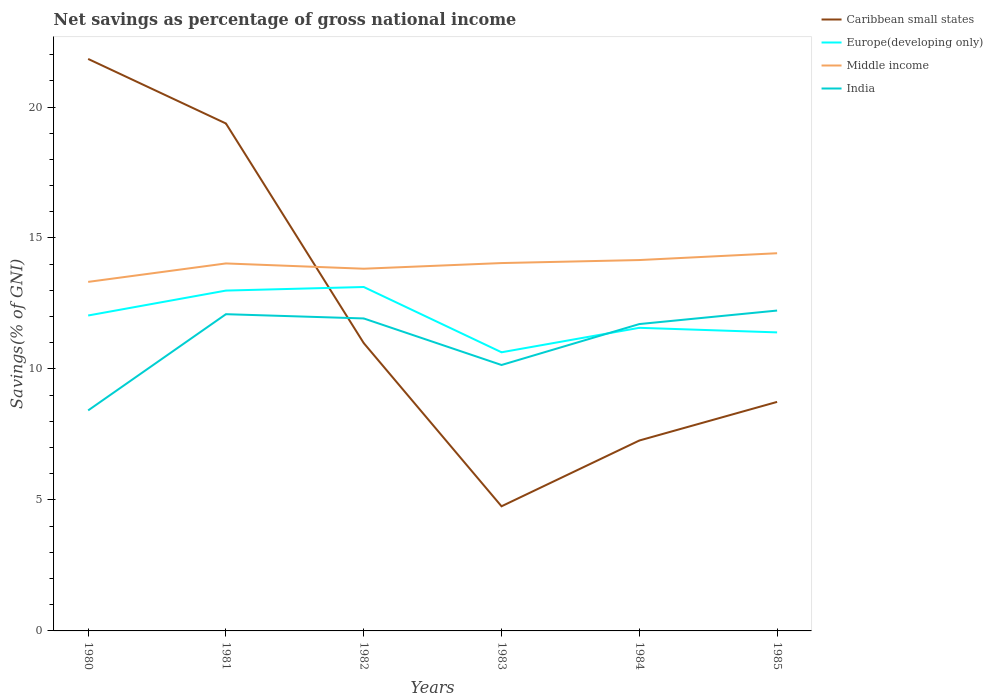How many different coloured lines are there?
Make the answer very short. 4. Does the line corresponding to India intersect with the line corresponding to Europe(developing only)?
Keep it short and to the point. Yes. Is the number of lines equal to the number of legend labels?
Ensure brevity in your answer.  Yes. Across all years, what is the maximum total savings in Middle income?
Keep it short and to the point. 13.32. In which year was the total savings in Caribbean small states maximum?
Your answer should be compact. 1983. What is the total total savings in Europe(developing only) in the graph?
Your response must be concise. 0.64. What is the difference between the highest and the second highest total savings in Caribbean small states?
Ensure brevity in your answer.  17.08. How many lines are there?
Give a very brief answer. 4. Are the values on the major ticks of Y-axis written in scientific E-notation?
Provide a short and direct response. No. Does the graph contain any zero values?
Provide a short and direct response. No. What is the title of the graph?
Offer a very short reply. Net savings as percentage of gross national income. What is the label or title of the Y-axis?
Provide a short and direct response. Savings(% of GNI). What is the Savings(% of GNI) of Caribbean small states in 1980?
Provide a succinct answer. 21.83. What is the Savings(% of GNI) of Europe(developing only) in 1980?
Your answer should be compact. 12.04. What is the Savings(% of GNI) of Middle income in 1980?
Keep it short and to the point. 13.32. What is the Savings(% of GNI) of India in 1980?
Give a very brief answer. 8.42. What is the Savings(% of GNI) of Caribbean small states in 1981?
Give a very brief answer. 19.37. What is the Savings(% of GNI) of Europe(developing only) in 1981?
Your answer should be very brief. 12.99. What is the Savings(% of GNI) in Middle income in 1981?
Provide a short and direct response. 14.03. What is the Savings(% of GNI) of India in 1981?
Offer a terse response. 12.09. What is the Savings(% of GNI) of Caribbean small states in 1982?
Offer a very short reply. 10.99. What is the Savings(% of GNI) of Europe(developing only) in 1982?
Offer a terse response. 13.13. What is the Savings(% of GNI) in Middle income in 1982?
Your answer should be compact. 13.83. What is the Savings(% of GNI) in India in 1982?
Provide a succinct answer. 11.93. What is the Savings(% of GNI) of Caribbean small states in 1983?
Offer a very short reply. 4.76. What is the Savings(% of GNI) of Europe(developing only) in 1983?
Keep it short and to the point. 10.64. What is the Savings(% of GNI) of Middle income in 1983?
Provide a succinct answer. 14.04. What is the Savings(% of GNI) in India in 1983?
Give a very brief answer. 10.15. What is the Savings(% of GNI) in Caribbean small states in 1984?
Keep it short and to the point. 7.27. What is the Savings(% of GNI) of Europe(developing only) in 1984?
Your answer should be very brief. 11.57. What is the Savings(% of GNI) in Middle income in 1984?
Ensure brevity in your answer.  14.16. What is the Savings(% of GNI) in India in 1984?
Ensure brevity in your answer.  11.71. What is the Savings(% of GNI) in Caribbean small states in 1985?
Offer a very short reply. 8.74. What is the Savings(% of GNI) of Europe(developing only) in 1985?
Make the answer very short. 11.4. What is the Savings(% of GNI) in Middle income in 1985?
Offer a terse response. 14.42. What is the Savings(% of GNI) of India in 1985?
Provide a succinct answer. 12.23. Across all years, what is the maximum Savings(% of GNI) of Caribbean small states?
Your answer should be compact. 21.83. Across all years, what is the maximum Savings(% of GNI) in Europe(developing only)?
Make the answer very short. 13.13. Across all years, what is the maximum Savings(% of GNI) in Middle income?
Your response must be concise. 14.42. Across all years, what is the maximum Savings(% of GNI) of India?
Provide a succinct answer. 12.23. Across all years, what is the minimum Savings(% of GNI) in Caribbean small states?
Your answer should be very brief. 4.76. Across all years, what is the minimum Savings(% of GNI) in Europe(developing only)?
Offer a terse response. 10.64. Across all years, what is the minimum Savings(% of GNI) of Middle income?
Your answer should be compact. 13.32. Across all years, what is the minimum Savings(% of GNI) of India?
Offer a very short reply. 8.42. What is the total Savings(% of GNI) in Caribbean small states in the graph?
Give a very brief answer. 72.96. What is the total Savings(% of GNI) of Europe(developing only) in the graph?
Provide a succinct answer. 71.77. What is the total Savings(% of GNI) in Middle income in the graph?
Make the answer very short. 83.8. What is the total Savings(% of GNI) of India in the graph?
Your response must be concise. 66.53. What is the difference between the Savings(% of GNI) in Caribbean small states in 1980 and that in 1981?
Offer a very short reply. 2.46. What is the difference between the Savings(% of GNI) of Europe(developing only) in 1980 and that in 1981?
Your response must be concise. -0.95. What is the difference between the Savings(% of GNI) of Middle income in 1980 and that in 1981?
Your response must be concise. -0.7. What is the difference between the Savings(% of GNI) in India in 1980 and that in 1981?
Give a very brief answer. -3.67. What is the difference between the Savings(% of GNI) of Caribbean small states in 1980 and that in 1982?
Keep it short and to the point. 10.85. What is the difference between the Savings(% of GNI) in Europe(developing only) in 1980 and that in 1982?
Your answer should be compact. -1.09. What is the difference between the Savings(% of GNI) in Middle income in 1980 and that in 1982?
Offer a terse response. -0.5. What is the difference between the Savings(% of GNI) in India in 1980 and that in 1982?
Your answer should be very brief. -3.51. What is the difference between the Savings(% of GNI) of Caribbean small states in 1980 and that in 1983?
Ensure brevity in your answer.  17.08. What is the difference between the Savings(% of GNI) of Europe(developing only) in 1980 and that in 1983?
Keep it short and to the point. 1.4. What is the difference between the Savings(% of GNI) in Middle income in 1980 and that in 1983?
Offer a terse response. -0.72. What is the difference between the Savings(% of GNI) of India in 1980 and that in 1983?
Ensure brevity in your answer.  -1.73. What is the difference between the Savings(% of GNI) of Caribbean small states in 1980 and that in 1984?
Provide a succinct answer. 14.57. What is the difference between the Savings(% of GNI) in Europe(developing only) in 1980 and that in 1984?
Offer a very short reply. 0.47. What is the difference between the Savings(% of GNI) in Middle income in 1980 and that in 1984?
Keep it short and to the point. -0.83. What is the difference between the Savings(% of GNI) in India in 1980 and that in 1984?
Provide a succinct answer. -3.3. What is the difference between the Savings(% of GNI) of Caribbean small states in 1980 and that in 1985?
Offer a terse response. 13.09. What is the difference between the Savings(% of GNI) in Europe(developing only) in 1980 and that in 1985?
Provide a short and direct response. 0.64. What is the difference between the Savings(% of GNI) of Middle income in 1980 and that in 1985?
Make the answer very short. -1.09. What is the difference between the Savings(% of GNI) of India in 1980 and that in 1985?
Provide a short and direct response. -3.81. What is the difference between the Savings(% of GNI) in Caribbean small states in 1981 and that in 1982?
Offer a very short reply. 8.38. What is the difference between the Savings(% of GNI) of Europe(developing only) in 1981 and that in 1982?
Provide a short and direct response. -0.14. What is the difference between the Savings(% of GNI) of Middle income in 1981 and that in 1982?
Your response must be concise. 0.2. What is the difference between the Savings(% of GNI) of India in 1981 and that in 1982?
Ensure brevity in your answer.  0.16. What is the difference between the Savings(% of GNI) in Caribbean small states in 1981 and that in 1983?
Your answer should be very brief. 14.61. What is the difference between the Savings(% of GNI) of Europe(developing only) in 1981 and that in 1983?
Provide a short and direct response. 2.36. What is the difference between the Savings(% of GNI) in Middle income in 1981 and that in 1983?
Keep it short and to the point. -0.01. What is the difference between the Savings(% of GNI) of India in 1981 and that in 1983?
Your answer should be very brief. 1.94. What is the difference between the Savings(% of GNI) in Caribbean small states in 1981 and that in 1984?
Ensure brevity in your answer.  12.1. What is the difference between the Savings(% of GNI) of Europe(developing only) in 1981 and that in 1984?
Your answer should be compact. 1.42. What is the difference between the Savings(% of GNI) of Middle income in 1981 and that in 1984?
Offer a very short reply. -0.13. What is the difference between the Savings(% of GNI) of India in 1981 and that in 1984?
Ensure brevity in your answer.  0.38. What is the difference between the Savings(% of GNI) in Caribbean small states in 1981 and that in 1985?
Offer a terse response. 10.63. What is the difference between the Savings(% of GNI) of Europe(developing only) in 1981 and that in 1985?
Give a very brief answer. 1.6. What is the difference between the Savings(% of GNI) of Middle income in 1981 and that in 1985?
Provide a succinct answer. -0.39. What is the difference between the Savings(% of GNI) in India in 1981 and that in 1985?
Make the answer very short. -0.14. What is the difference between the Savings(% of GNI) in Caribbean small states in 1982 and that in 1983?
Offer a terse response. 6.23. What is the difference between the Savings(% of GNI) of Europe(developing only) in 1982 and that in 1983?
Your answer should be compact. 2.49. What is the difference between the Savings(% of GNI) in Middle income in 1982 and that in 1983?
Make the answer very short. -0.22. What is the difference between the Savings(% of GNI) of India in 1982 and that in 1983?
Keep it short and to the point. 1.78. What is the difference between the Savings(% of GNI) in Caribbean small states in 1982 and that in 1984?
Provide a succinct answer. 3.72. What is the difference between the Savings(% of GNI) in Europe(developing only) in 1982 and that in 1984?
Ensure brevity in your answer.  1.56. What is the difference between the Savings(% of GNI) of Middle income in 1982 and that in 1984?
Make the answer very short. -0.33. What is the difference between the Savings(% of GNI) in India in 1982 and that in 1984?
Your answer should be very brief. 0.21. What is the difference between the Savings(% of GNI) in Caribbean small states in 1982 and that in 1985?
Make the answer very short. 2.25. What is the difference between the Savings(% of GNI) in Europe(developing only) in 1982 and that in 1985?
Keep it short and to the point. 1.73. What is the difference between the Savings(% of GNI) of Middle income in 1982 and that in 1985?
Your answer should be compact. -0.59. What is the difference between the Savings(% of GNI) of India in 1982 and that in 1985?
Offer a very short reply. -0.3. What is the difference between the Savings(% of GNI) of Caribbean small states in 1983 and that in 1984?
Keep it short and to the point. -2.51. What is the difference between the Savings(% of GNI) of Europe(developing only) in 1983 and that in 1984?
Keep it short and to the point. -0.93. What is the difference between the Savings(% of GNI) of Middle income in 1983 and that in 1984?
Keep it short and to the point. -0.12. What is the difference between the Savings(% of GNI) of India in 1983 and that in 1984?
Ensure brevity in your answer.  -1.56. What is the difference between the Savings(% of GNI) in Caribbean small states in 1983 and that in 1985?
Your response must be concise. -3.98. What is the difference between the Savings(% of GNI) in Europe(developing only) in 1983 and that in 1985?
Your response must be concise. -0.76. What is the difference between the Savings(% of GNI) in Middle income in 1983 and that in 1985?
Provide a succinct answer. -0.38. What is the difference between the Savings(% of GNI) in India in 1983 and that in 1985?
Ensure brevity in your answer.  -2.08. What is the difference between the Savings(% of GNI) of Caribbean small states in 1984 and that in 1985?
Your answer should be very brief. -1.47. What is the difference between the Savings(% of GNI) of Europe(developing only) in 1984 and that in 1985?
Make the answer very short. 0.17. What is the difference between the Savings(% of GNI) in Middle income in 1984 and that in 1985?
Give a very brief answer. -0.26. What is the difference between the Savings(% of GNI) of India in 1984 and that in 1985?
Ensure brevity in your answer.  -0.52. What is the difference between the Savings(% of GNI) in Caribbean small states in 1980 and the Savings(% of GNI) in Europe(developing only) in 1981?
Give a very brief answer. 8.84. What is the difference between the Savings(% of GNI) in Caribbean small states in 1980 and the Savings(% of GNI) in Middle income in 1981?
Your response must be concise. 7.81. What is the difference between the Savings(% of GNI) of Caribbean small states in 1980 and the Savings(% of GNI) of India in 1981?
Provide a short and direct response. 9.74. What is the difference between the Savings(% of GNI) in Europe(developing only) in 1980 and the Savings(% of GNI) in Middle income in 1981?
Offer a very short reply. -1.99. What is the difference between the Savings(% of GNI) of Europe(developing only) in 1980 and the Savings(% of GNI) of India in 1981?
Provide a short and direct response. -0.05. What is the difference between the Savings(% of GNI) of Middle income in 1980 and the Savings(% of GNI) of India in 1981?
Keep it short and to the point. 1.23. What is the difference between the Savings(% of GNI) of Caribbean small states in 1980 and the Savings(% of GNI) of Europe(developing only) in 1982?
Your response must be concise. 8.71. What is the difference between the Savings(% of GNI) of Caribbean small states in 1980 and the Savings(% of GNI) of Middle income in 1982?
Your answer should be compact. 8.01. What is the difference between the Savings(% of GNI) of Caribbean small states in 1980 and the Savings(% of GNI) of India in 1982?
Give a very brief answer. 9.91. What is the difference between the Savings(% of GNI) of Europe(developing only) in 1980 and the Savings(% of GNI) of Middle income in 1982?
Offer a very short reply. -1.79. What is the difference between the Savings(% of GNI) in Europe(developing only) in 1980 and the Savings(% of GNI) in India in 1982?
Your answer should be compact. 0.11. What is the difference between the Savings(% of GNI) of Middle income in 1980 and the Savings(% of GNI) of India in 1982?
Your answer should be compact. 1.4. What is the difference between the Savings(% of GNI) in Caribbean small states in 1980 and the Savings(% of GNI) in Europe(developing only) in 1983?
Give a very brief answer. 11.2. What is the difference between the Savings(% of GNI) in Caribbean small states in 1980 and the Savings(% of GNI) in Middle income in 1983?
Your answer should be very brief. 7.79. What is the difference between the Savings(% of GNI) of Caribbean small states in 1980 and the Savings(% of GNI) of India in 1983?
Ensure brevity in your answer.  11.68. What is the difference between the Savings(% of GNI) in Europe(developing only) in 1980 and the Savings(% of GNI) in Middle income in 1983?
Provide a short and direct response. -2. What is the difference between the Savings(% of GNI) of Europe(developing only) in 1980 and the Savings(% of GNI) of India in 1983?
Give a very brief answer. 1.89. What is the difference between the Savings(% of GNI) of Middle income in 1980 and the Savings(% of GNI) of India in 1983?
Your response must be concise. 3.17. What is the difference between the Savings(% of GNI) in Caribbean small states in 1980 and the Savings(% of GNI) in Europe(developing only) in 1984?
Your response must be concise. 10.26. What is the difference between the Savings(% of GNI) of Caribbean small states in 1980 and the Savings(% of GNI) of Middle income in 1984?
Keep it short and to the point. 7.68. What is the difference between the Savings(% of GNI) of Caribbean small states in 1980 and the Savings(% of GNI) of India in 1984?
Ensure brevity in your answer.  10.12. What is the difference between the Savings(% of GNI) in Europe(developing only) in 1980 and the Savings(% of GNI) in Middle income in 1984?
Give a very brief answer. -2.12. What is the difference between the Savings(% of GNI) in Europe(developing only) in 1980 and the Savings(% of GNI) in India in 1984?
Offer a very short reply. 0.33. What is the difference between the Savings(% of GNI) of Middle income in 1980 and the Savings(% of GNI) of India in 1984?
Offer a very short reply. 1.61. What is the difference between the Savings(% of GNI) in Caribbean small states in 1980 and the Savings(% of GNI) in Europe(developing only) in 1985?
Your answer should be compact. 10.44. What is the difference between the Savings(% of GNI) in Caribbean small states in 1980 and the Savings(% of GNI) in Middle income in 1985?
Your answer should be very brief. 7.42. What is the difference between the Savings(% of GNI) in Caribbean small states in 1980 and the Savings(% of GNI) in India in 1985?
Your answer should be compact. 9.61. What is the difference between the Savings(% of GNI) in Europe(developing only) in 1980 and the Savings(% of GNI) in Middle income in 1985?
Give a very brief answer. -2.38. What is the difference between the Savings(% of GNI) in Europe(developing only) in 1980 and the Savings(% of GNI) in India in 1985?
Provide a short and direct response. -0.19. What is the difference between the Savings(% of GNI) of Middle income in 1980 and the Savings(% of GNI) of India in 1985?
Ensure brevity in your answer.  1.09. What is the difference between the Savings(% of GNI) in Caribbean small states in 1981 and the Savings(% of GNI) in Europe(developing only) in 1982?
Ensure brevity in your answer.  6.24. What is the difference between the Savings(% of GNI) in Caribbean small states in 1981 and the Savings(% of GNI) in Middle income in 1982?
Provide a succinct answer. 5.54. What is the difference between the Savings(% of GNI) in Caribbean small states in 1981 and the Savings(% of GNI) in India in 1982?
Provide a short and direct response. 7.44. What is the difference between the Savings(% of GNI) of Europe(developing only) in 1981 and the Savings(% of GNI) of Middle income in 1982?
Offer a very short reply. -0.83. What is the difference between the Savings(% of GNI) of Europe(developing only) in 1981 and the Savings(% of GNI) of India in 1982?
Make the answer very short. 1.06. What is the difference between the Savings(% of GNI) in Middle income in 1981 and the Savings(% of GNI) in India in 1982?
Keep it short and to the point. 2.1. What is the difference between the Savings(% of GNI) in Caribbean small states in 1981 and the Savings(% of GNI) in Europe(developing only) in 1983?
Your response must be concise. 8.73. What is the difference between the Savings(% of GNI) in Caribbean small states in 1981 and the Savings(% of GNI) in Middle income in 1983?
Provide a succinct answer. 5.33. What is the difference between the Savings(% of GNI) of Caribbean small states in 1981 and the Savings(% of GNI) of India in 1983?
Provide a short and direct response. 9.22. What is the difference between the Savings(% of GNI) of Europe(developing only) in 1981 and the Savings(% of GNI) of Middle income in 1983?
Offer a very short reply. -1.05. What is the difference between the Savings(% of GNI) of Europe(developing only) in 1981 and the Savings(% of GNI) of India in 1983?
Your answer should be compact. 2.84. What is the difference between the Savings(% of GNI) in Middle income in 1981 and the Savings(% of GNI) in India in 1983?
Ensure brevity in your answer.  3.88. What is the difference between the Savings(% of GNI) in Caribbean small states in 1981 and the Savings(% of GNI) in Europe(developing only) in 1984?
Offer a terse response. 7.8. What is the difference between the Savings(% of GNI) of Caribbean small states in 1981 and the Savings(% of GNI) of Middle income in 1984?
Your answer should be very brief. 5.21. What is the difference between the Savings(% of GNI) in Caribbean small states in 1981 and the Savings(% of GNI) in India in 1984?
Your answer should be compact. 7.66. What is the difference between the Savings(% of GNI) of Europe(developing only) in 1981 and the Savings(% of GNI) of Middle income in 1984?
Provide a short and direct response. -1.17. What is the difference between the Savings(% of GNI) in Europe(developing only) in 1981 and the Savings(% of GNI) in India in 1984?
Provide a short and direct response. 1.28. What is the difference between the Savings(% of GNI) of Middle income in 1981 and the Savings(% of GNI) of India in 1984?
Provide a succinct answer. 2.31. What is the difference between the Savings(% of GNI) in Caribbean small states in 1981 and the Savings(% of GNI) in Europe(developing only) in 1985?
Give a very brief answer. 7.97. What is the difference between the Savings(% of GNI) in Caribbean small states in 1981 and the Savings(% of GNI) in Middle income in 1985?
Provide a succinct answer. 4.95. What is the difference between the Savings(% of GNI) in Caribbean small states in 1981 and the Savings(% of GNI) in India in 1985?
Offer a terse response. 7.14. What is the difference between the Savings(% of GNI) in Europe(developing only) in 1981 and the Savings(% of GNI) in Middle income in 1985?
Your answer should be very brief. -1.43. What is the difference between the Savings(% of GNI) in Europe(developing only) in 1981 and the Savings(% of GNI) in India in 1985?
Your answer should be very brief. 0.76. What is the difference between the Savings(% of GNI) of Middle income in 1981 and the Savings(% of GNI) of India in 1985?
Your response must be concise. 1.8. What is the difference between the Savings(% of GNI) in Caribbean small states in 1982 and the Savings(% of GNI) in Europe(developing only) in 1983?
Give a very brief answer. 0.35. What is the difference between the Savings(% of GNI) of Caribbean small states in 1982 and the Savings(% of GNI) of Middle income in 1983?
Provide a short and direct response. -3.05. What is the difference between the Savings(% of GNI) in Caribbean small states in 1982 and the Savings(% of GNI) in India in 1983?
Provide a succinct answer. 0.84. What is the difference between the Savings(% of GNI) in Europe(developing only) in 1982 and the Savings(% of GNI) in Middle income in 1983?
Offer a very short reply. -0.91. What is the difference between the Savings(% of GNI) of Europe(developing only) in 1982 and the Savings(% of GNI) of India in 1983?
Make the answer very short. 2.98. What is the difference between the Savings(% of GNI) of Middle income in 1982 and the Savings(% of GNI) of India in 1983?
Provide a short and direct response. 3.68. What is the difference between the Savings(% of GNI) of Caribbean small states in 1982 and the Savings(% of GNI) of Europe(developing only) in 1984?
Offer a terse response. -0.58. What is the difference between the Savings(% of GNI) of Caribbean small states in 1982 and the Savings(% of GNI) of Middle income in 1984?
Your response must be concise. -3.17. What is the difference between the Savings(% of GNI) of Caribbean small states in 1982 and the Savings(% of GNI) of India in 1984?
Your answer should be compact. -0.73. What is the difference between the Savings(% of GNI) of Europe(developing only) in 1982 and the Savings(% of GNI) of Middle income in 1984?
Provide a succinct answer. -1.03. What is the difference between the Savings(% of GNI) of Europe(developing only) in 1982 and the Savings(% of GNI) of India in 1984?
Provide a succinct answer. 1.41. What is the difference between the Savings(% of GNI) of Middle income in 1982 and the Savings(% of GNI) of India in 1984?
Offer a very short reply. 2.11. What is the difference between the Savings(% of GNI) in Caribbean small states in 1982 and the Savings(% of GNI) in Europe(developing only) in 1985?
Your answer should be compact. -0.41. What is the difference between the Savings(% of GNI) of Caribbean small states in 1982 and the Savings(% of GNI) of Middle income in 1985?
Ensure brevity in your answer.  -3.43. What is the difference between the Savings(% of GNI) in Caribbean small states in 1982 and the Savings(% of GNI) in India in 1985?
Your response must be concise. -1.24. What is the difference between the Savings(% of GNI) in Europe(developing only) in 1982 and the Savings(% of GNI) in Middle income in 1985?
Your response must be concise. -1.29. What is the difference between the Savings(% of GNI) in Europe(developing only) in 1982 and the Savings(% of GNI) in India in 1985?
Offer a terse response. 0.9. What is the difference between the Savings(% of GNI) in Middle income in 1982 and the Savings(% of GNI) in India in 1985?
Your answer should be very brief. 1.6. What is the difference between the Savings(% of GNI) in Caribbean small states in 1983 and the Savings(% of GNI) in Europe(developing only) in 1984?
Make the answer very short. -6.81. What is the difference between the Savings(% of GNI) in Caribbean small states in 1983 and the Savings(% of GNI) in Middle income in 1984?
Your answer should be very brief. -9.4. What is the difference between the Savings(% of GNI) in Caribbean small states in 1983 and the Savings(% of GNI) in India in 1984?
Provide a succinct answer. -6.96. What is the difference between the Savings(% of GNI) of Europe(developing only) in 1983 and the Savings(% of GNI) of Middle income in 1984?
Ensure brevity in your answer.  -3.52. What is the difference between the Savings(% of GNI) of Europe(developing only) in 1983 and the Savings(% of GNI) of India in 1984?
Provide a short and direct response. -1.08. What is the difference between the Savings(% of GNI) in Middle income in 1983 and the Savings(% of GNI) in India in 1984?
Make the answer very short. 2.33. What is the difference between the Savings(% of GNI) in Caribbean small states in 1983 and the Savings(% of GNI) in Europe(developing only) in 1985?
Your answer should be very brief. -6.64. What is the difference between the Savings(% of GNI) in Caribbean small states in 1983 and the Savings(% of GNI) in Middle income in 1985?
Give a very brief answer. -9.66. What is the difference between the Savings(% of GNI) in Caribbean small states in 1983 and the Savings(% of GNI) in India in 1985?
Provide a succinct answer. -7.47. What is the difference between the Savings(% of GNI) of Europe(developing only) in 1983 and the Savings(% of GNI) of Middle income in 1985?
Give a very brief answer. -3.78. What is the difference between the Savings(% of GNI) of Europe(developing only) in 1983 and the Savings(% of GNI) of India in 1985?
Your answer should be very brief. -1.59. What is the difference between the Savings(% of GNI) in Middle income in 1983 and the Savings(% of GNI) in India in 1985?
Your answer should be very brief. 1.81. What is the difference between the Savings(% of GNI) of Caribbean small states in 1984 and the Savings(% of GNI) of Europe(developing only) in 1985?
Your response must be concise. -4.13. What is the difference between the Savings(% of GNI) of Caribbean small states in 1984 and the Savings(% of GNI) of Middle income in 1985?
Your answer should be very brief. -7.15. What is the difference between the Savings(% of GNI) of Caribbean small states in 1984 and the Savings(% of GNI) of India in 1985?
Keep it short and to the point. -4.96. What is the difference between the Savings(% of GNI) of Europe(developing only) in 1984 and the Savings(% of GNI) of Middle income in 1985?
Keep it short and to the point. -2.85. What is the difference between the Savings(% of GNI) of Europe(developing only) in 1984 and the Savings(% of GNI) of India in 1985?
Your answer should be compact. -0.66. What is the difference between the Savings(% of GNI) in Middle income in 1984 and the Savings(% of GNI) in India in 1985?
Provide a succinct answer. 1.93. What is the average Savings(% of GNI) of Caribbean small states per year?
Make the answer very short. 12.16. What is the average Savings(% of GNI) in Europe(developing only) per year?
Give a very brief answer. 11.96. What is the average Savings(% of GNI) in Middle income per year?
Your response must be concise. 13.97. What is the average Savings(% of GNI) of India per year?
Give a very brief answer. 11.09. In the year 1980, what is the difference between the Savings(% of GNI) of Caribbean small states and Savings(% of GNI) of Europe(developing only)?
Provide a short and direct response. 9.79. In the year 1980, what is the difference between the Savings(% of GNI) of Caribbean small states and Savings(% of GNI) of Middle income?
Keep it short and to the point. 8.51. In the year 1980, what is the difference between the Savings(% of GNI) in Caribbean small states and Savings(% of GNI) in India?
Ensure brevity in your answer.  13.42. In the year 1980, what is the difference between the Savings(% of GNI) of Europe(developing only) and Savings(% of GNI) of Middle income?
Offer a terse response. -1.28. In the year 1980, what is the difference between the Savings(% of GNI) of Europe(developing only) and Savings(% of GNI) of India?
Offer a terse response. 3.62. In the year 1980, what is the difference between the Savings(% of GNI) in Middle income and Savings(% of GNI) in India?
Provide a short and direct response. 4.91. In the year 1981, what is the difference between the Savings(% of GNI) in Caribbean small states and Savings(% of GNI) in Europe(developing only)?
Offer a terse response. 6.38. In the year 1981, what is the difference between the Savings(% of GNI) of Caribbean small states and Savings(% of GNI) of Middle income?
Offer a very short reply. 5.34. In the year 1981, what is the difference between the Savings(% of GNI) of Caribbean small states and Savings(% of GNI) of India?
Your answer should be compact. 7.28. In the year 1981, what is the difference between the Savings(% of GNI) in Europe(developing only) and Savings(% of GNI) in Middle income?
Provide a short and direct response. -1.04. In the year 1981, what is the difference between the Savings(% of GNI) in Europe(developing only) and Savings(% of GNI) in India?
Offer a terse response. 0.9. In the year 1981, what is the difference between the Savings(% of GNI) of Middle income and Savings(% of GNI) of India?
Give a very brief answer. 1.94. In the year 1982, what is the difference between the Savings(% of GNI) in Caribbean small states and Savings(% of GNI) in Europe(developing only)?
Give a very brief answer. -2.14. In the year 1982, what is the difference between the Savings(% of GNI) in Caribbean small states and Savings(% of GNI) in Middle income?
Ensure brevity in your answer.  -2.84. In the year 1982, what is the difference between the Savings(% of GNI) of Caribbean small states and Savings(% of GNI) of India?
Ensure brevity in your answer.  -0.94. In the year 1982, what is the difference between the Savings(% of GNI) of Europe(developing only) and Savings(% of GNI) of Middle income?
Offer a very short reply. -0.7. In the year 1982, what is the difference between the Savings(% of GNI) in Europe(developing only) and Savings(% of GNI) in India?
Provide a succinct answer. 1.2. In the year 1982, what is the difference between the Savings(% of GNI) of Middle income and Savings(% of GNI) of India?
Offer a very short reply. 1.9. In the year 1983, what is the difference between the Savings(% of GNI) of Caribbean small states and Savings(% of GNI) of Europe(developing only)?
Your response must be concise. -5.88. In the year 1983, what is the difference between the Savings(% of GNI) of Caribbean small states and Savings(% of GNI) of Middle income?
Your answer should be very brief. -9.28. In the year 1983, what is the difference between the Savings(% of GNI) of Caribbean small states and Savings(% of GNI) of India?
Make the answer very short. -5.39. In the year 1983, what is the difference between the Savings(% of GNI) in Europe(developing only) and Savings(% of GNI) in Middle income?
Make the answer very short. -3.41. In the year 1983, what is the difference between the Savings(% of GNI) of Europe(developing only) and Savings(% of GNI) of India?
Your answer should be very brief. 0.49. In the year 1983, what is the difference between the Savings(% of GNI) in Middle income and Savings(% of GNI) in India?
Offer a terse response. 3.89. In the year 1984, what is the difference between the Savings(% of GNI) of Caribbean small states and Savings(% of GNI) of Europe(developing only)?
Offer a very short reply. -4.3. In the year 1984, what is the difference between the Savings(% of GNI) in Caribbean small states and Savings(% of GNI) in Middle income?
Provide a short and direct response. -6.89. In the year 1984, what is the difference between the Savings(% of GNI) of Caribbean small states and Savings(% of GNI) of India?
Make the answer very short. -4.45. In the year 1984, what is the difference between the Savings(% of GNI) of Europe(developing only) and Savings(% of GNI) of Middle income?
Make the answer very short. -2.59. In the year 1984, what is the difference between the Savings(% of GNI) in Europe(developing only) and Savings(% of GNI) in India?
Your response must be concise. -0.14. In the year 1984, what is the difference between the Savings(% of GNI) in Middle income and Savings(% of GNI) in India?
Provide a succinct answer. 2.44. In the year 1985, what is the difference between the Savings(% of GNI) in Caribbean small states and Savings(% of GNI) in Europe(developing only)?
Keep it short and to the point. -2.65. In the year 1985, what is the difference between the Savings(% of GNI) in Caribbean small states and Savings(% of GNI) in Middle income?
Offer a terse response. -5.68. In the year 1985, what is the difference between the Savings(% of GNI) of Caribbean small states and Savings(% of GNI) of India?
Provide a short and direct response. -3.49. In the year 1985, what is the difference between the Savings(% of GNI) of Europe(developing only) and Savings(% of GNI) of Middle income?
Provide a short and direct response. -3.02. In the year 1985, what is the difference between the Savings(% of GNI) in Europe(developing only) and Savings(% of GNI) in India?
Keep it short and to the point. -0.83. In the year 1985, what is the difference between the Savings(% of GNI) in Middle income and Savings(% of GNI) in India?
Provide a succinct answer. 2.19. What is the ratio of the Savings(% of GNI) in Caribbean small states in 1980 to that in 1981?
Offer a terse response. 1.13. What is the ratio of the Savings(% of GNI) in Europe(developing only) in 1980 to that in 1981?
Keep it short and to the point. 0.93. What is the ratio of the Savings(% of GNI) of Middle income in 1980 to that in 1981?
Offer a very short reply. 0.95. What is the ratio of the Savings(% of GNI) of India in 1980 to that in 1981?
Offer a terse response. 0.7. What is the ratio of the Savings(% of GNI) in Caribbean small states in 1980 to that in 1982?
Provide a succinct answer. 1.99. What is the ratio of the Savings(% of GNI) of Europe(developing only) in 1980 to that in 1982?
Provide a succinct answer. 0.92. What is the ratio of the Savings(% of GNI) in Middle income in 1980 to that in 1982?
Provide a short and direct response. 0.96. What is the ratio of the Savings(% of GNI) of India in 1980 to that in 1982?
Give a very brief answer. 0.71. What is the ratio of the Savings(% of GNI) of Caribbean small states in 1980 to that in 1983?
Your answer should be compact. 4.59. What is the ratio of the Savings(% of GNI) in Europe(developing only) in 1980 to that in 1983?
Make the answer very short. 1.13. What is the ratio of the Savings(% of GNI) of Middle income in 1980 to that in 1983?
Your response must be concise. 0.95. What is the ratio of the Savings(% of GNI) in India in 1980 to that in 1983?
Ensure brevity in your answer.  0.83. What is the ratio of the Savings(% of GNI) of Caribbean small states in 1980 to that in 1984?
Your answer should be compact. 3. What is the ratio of the Savings(% of GNI) of Europe(developing only) in 1980 to that in 1984?
Make the answer very short. 1.04. What is the ratio of the Savings(% of GNI) in Middle income in 1980 to that in 1984?
Provide a succinct answer. 0.94. What is the ratio of the Savings(% of GNI) in India in 1980 to that in 1984?
Make the answer very short. 0.72. What is the ratio of the Savings(% of GNI) in Caribbean small states in 1980 to that in 1985?
Give a very brief answer. 2.5. What is the ratio of the Savings(% of GNI) in Europe(developing only) in 1980 to that in 1985?
Offer a terse response. 1.06. What is the ratio of the Savings(% of GNI) in Middle income in 1980 to that in 1985?
Offer a very short reply. 0.92. What is the ratio of the Savings(% of GNI) in India in 1980 to that in 1985?
Your answer should be very brief. 0.69. What is the ratio of the Savings(% of GNI) in Caribbean small states in 1981 to that in 1982?
Keep it short and to the point. 1.76. What is the ratio of the Savings(% of GNI) of Middle income in 1981 to that in 1982?
Provide a succinct answer. 1.01. What is the ratio of the Savings(% of GNI) in India in 1981 to that in 1982?
Offer a terse response. 1.01. What is the ratio of the Savings(% of GNI) in Caribbean small states in 1981 to that in 1983?
Make the answer very short. 4.07. What is the ratio of the Savings(% of GNI) of Europe(developing only) in 1981 to that in 1983?
Give a very brief answer. 1.22. What is the ratio of the Savings(% of GNI) of India in 1981 to that in 1983?
Your response must be concise. 1.19. What is the ratio of the Savings(% of GNI) of Caribbean small states in 1981 to that in 1984?
Provide a succinct answer. 2.67. What is the ratio of the Savings(% of GNI) in Europe(developing only) in 1981 to that in 1984?
Provide a succinct answer. 1.12. What is the ratio of the Savings(% of GNI) in Middle income in 1981 to that in 1984?
Your response must be concise. 0.99. What is the ratio of the Savings(% of GNI) of India in 1981 to that in 1984?
Offer a terse response. 1.03. What is the ratio of the Savings(% of GNI) of Caribbean small states in 1981 to that in 1985?
Offer a terse response. 2.22. What is the ratio of the Savings(% of GNI) in Europe(developing only) in 1981 to that in 1985?
Keep it short and to the point. 1.14. What is the ratio of the Savings(% of GNI) in India in 1981 to that in 1985?
Keep it short and to the point. 0.99. What is the ratio of the Savings(% of GNI) of Caribbean small states in 1982 to that in 1983?
Provide a succinct answer. 2.31. What is the ratio of the Savings(% of GNI) in Europe(developing only) in 1982 to that in 1983?
Your response must be concise. 1.23. What is the ratio of the Savings(% of GNI) in Middle income in 1982 to that in 1983?
Give a very brief answer. 0.98. What is the ratio of the Savings(% of GNI) in India in 1982 to that in 1983?
Provide a succinct answer. 1.18. What is the ratio of the Savings(% of GNI) of Caribbean small states in 1982 to that in 1984?
Make the answer very short. 1.51. What is the ratio of the Savings(% of GNI) of Europe(developing only) in 1982 to that in 1984?
Your answer should be very brief. 1.13. What is the ratio of the Savings(% of GNI) in Middle income in 1982 to that in 1984?
Keep it short and to the point. 0.98. What is the ratio of the Savings(% of GNI) of India in 1982 to that in 1984?
Provide a short and direct response. 1.02. What is the ratio of the Savings(% of GNI) of Caribbean small states in 1982 to that in 1985?
Make the answer very short. 1.26. What is the ratio of the Savings(% of GNI) of Europe(developing only) in 1982 to that in 1985?
Offer a very short reply. 1.15. What is the ratio of the Savings(% of GNI) of Middle income in 1982 to that in 1985?
Keep it short and to the point. 0.96. What is the ratio of the Savings(% of GNI) of India in 1982 to that in 1985?
Provide a short and direct response. 0.98. What is the ratio of the Savings(% of GNI) of Caribbean small states in 1983 to that in 1984?
Offer a terse response. 0.65. What is the ratio of the Savings(% of GNI) in Europe(developing only) in 1983 to that in 1984?
Your answer should be very brief. 0.92. What is the ratio of the Savings(% of GNI) of India in 1983 to that in 1984?
Keep it short and to the point. 0.87. What is the ratio of the Savings(% of GNI) of Caribbean small states in 1983 to that in 1985?
Your response must be concise. 0.54. What is the ratio of the Savings(% of GNI) of Europe(developing only) in 1983 to that in 1985?
Give a very brief answer. 0.93. What is the ratio of the Savings(% of GNI) in Middle income in 1983 to that in 1985?
Your answer should be compact. 0.97. What is the ratio of the Savings(% of GNI) in India in 1983 to that in 1985?
Ensure brevity in your answer.  0.83. What is the ratio of the Savings(% of GNI) in Caribbean small states in 1984 to that in 1985?
Make the answer very short. 0.83. What is the ratio of the Savings(% of GNI) of Europe(developing only) in 1984 to that in 1985?
Your answer should be compact. 1.02. What is the ratio of the Savings(% of GNI) in Middle income in 1984 to that in 1985?
Make the answer very short. 0.98. What is the ratio of the Savings(% of GNI) of India in 1984 to that in 1985?
Your response must be concise. 0.96. What is the difference between the highest and the second highest Savings(% of GNI) in Caribbean small states?
Your response must be concise. 2.46. What is the difference between the highest and the second highest Savings(% of GNI) in Europe(developing only)?
Offer a terse response. 0.14. What is the difference between the highest and the second highest Savings(% of GNI) of Middle income?
Provide a short and direct response. 0.26. What is the difference between the highest and the second highest Savings(% of GNI) of India?
Ensure brevity in your answer.  0.14. What is the difference between the highest and the lowest Savings(% of GNI) in Caribbean small states?
Offer a terse response. 17.08. What is the difference between the highest and the lowest Savings(% of GNI) of Europe(developing only)?
Give a very brief answer. 2.49. What is the difference between the highest and the lowest Savings(% of GNI) in Middle income?
Your answer should be compact. 1.09. What is the difference between the highest and the lowest Savings(% of GNI) of India?
Your answer should be very brief. 3.81. 